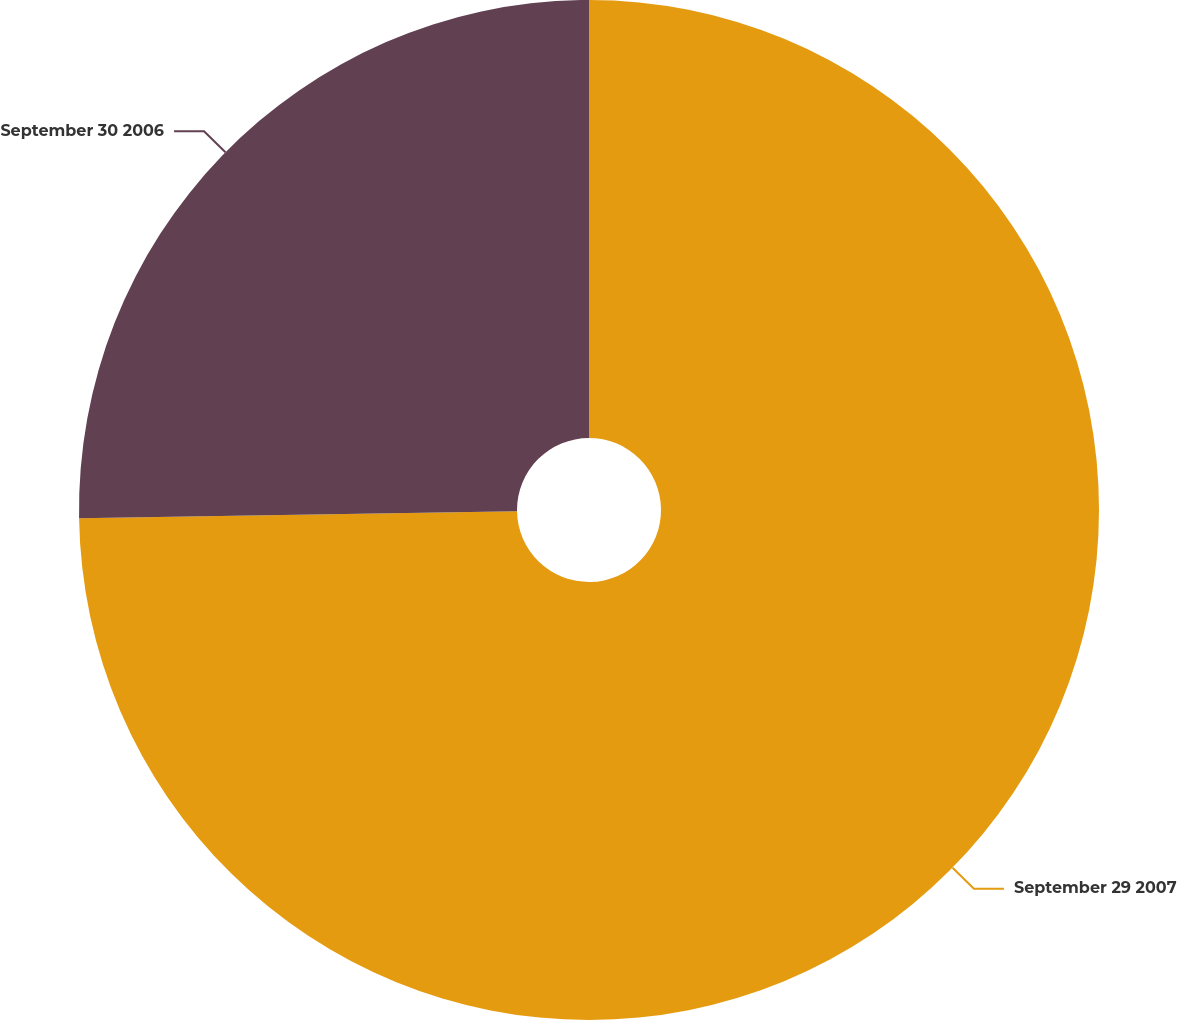Convert chart to OTSL. <chart><loc_0><loc_0><loc_500><loc_500><pie_chart><fcel>September 29 2007<fcel>September 30 2006<nl><fcel>74.74%<fcel>25.26%<nl></chart> 